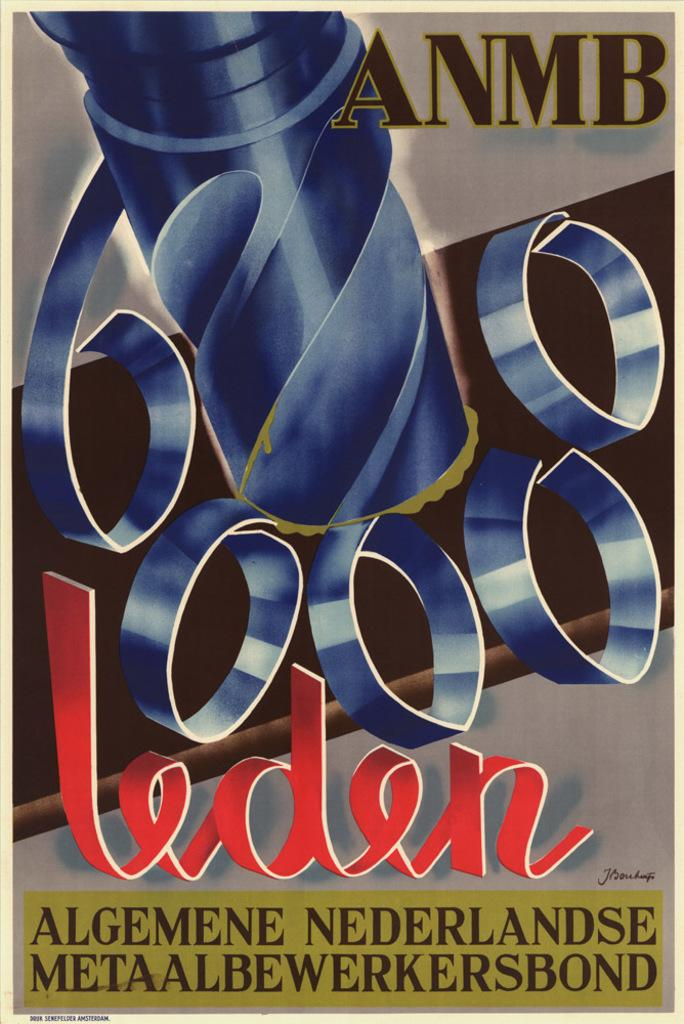<image>
Write a terse but informative summary of the picture. A poster shows a drill and has the text "6000 leden". 